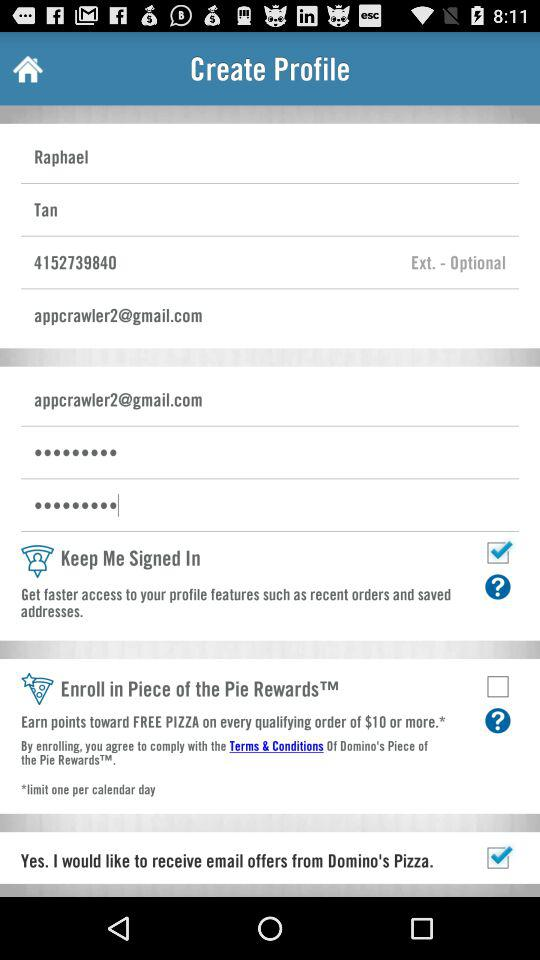What's the status of "Keep Me Signed In"? The status is "on". 